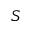Convert formula to latex. <formula><loc_0><loc_0><loc_500><loc_500>S</formula> 